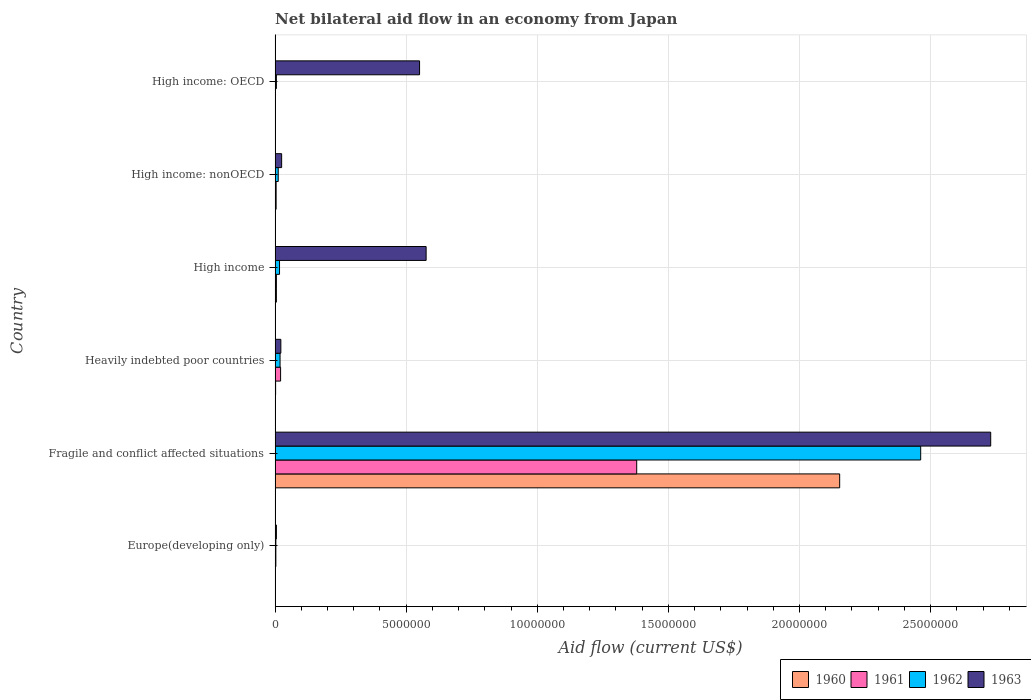How many different coloured bars are there?
Make the answer very short. 4. Are the number of bars per tick equal to the number of legend labels?
Offer a terse response. Yes. Are the number of bars on each tick of the Y-axis equal?
Provide a short and direct response. Yes. How many bars are there on the 4th tick from the bottom?
Offer a terse response. 4. What is the label of the 4th group of bars from the top?
Provide a succinct answer. Heavily indebted poor countries. Across all countries, what is the maximum net bilateral aid flow in 1962?
Offer a terse response. 2.46e+07. Across all countries, what is the minimum net bilateral aid flow in 1961?
Provide a succinct answer. 10000. In which country was the net bilateral aid flow in 1962 maximum?
Ensure brevity in your answer.  Fragile and conflict affected situations. In which country was the net bilateral aid flow in 1963 minimum?
Provide a succinct answer. Europe(developing only). What is the total net bilateral aid flow in 1960 in the graph?
Offer a very short reply. 2.17e+07. What is the difference between the net bilateral aid flow in 1960 in Europe(developing only) and that in Heavily indebted poor countries?
Make the answer very short. -10000. What is the difference between the net bilateral aid flow in 1962 in Heavily indebted poor countries and the net bilateral aid flow in 1960 in Fragile and conflict affected situations?
Provide a short and direct response. -2.13e+07. What is the average net bilateral aid flow in 1960 per country?
Offer a very short reply. 3.61e+06. What is the difference between the net bilateral aid flow in 1960 and net bilateral aid flow in 1961 in High income?
Provide a succinct answer. 0. In how many countries, is the net bilateral aid flow in 1962 greater than 26000000 US$?
Offer a very short reply. 0. What is the ratio of the net bilateral aid flow in 1961 in Heavily indebted poor countries to that in High income: nonOECD?
Your response must be concise. 5.25. What is the difference between the highest and the second highest net bilateral aid flow in 1960?
Make the answer very short. 2.15e+07. What is the difference between the highest and the lowest net bilateral aid flow in 1962?
Offer a terse response. 2.46e+07. What does the 3rd bar from the top in High income represents?
Provide a short and direct response. 1961. What does the 4th bar from the bottom in High income: OECD represents?
Make the answer very short. 1963. Are all the bars in the graph horizontal?
Your response must be concise. Yes. What is the difference between two consecutive major ticks on the X-axis?
Your response must be concise. 5.00e+06. Are the values on the major ticks of X-axis written in scientific E-notation?
Provide a succinct answer. No. Does the graph contain any zero values?
Keep it short and to the point. No. Does the graph contain grids?
Keep it short and to the point. Yes. How many legend labels are there?
Keep it short and to the point. 4. What is the title of the graph?
Your answer should be compact. Net bilateral aid flow in an economy from Japan. What is the label or title of the X-axis?
Your response must be concise. Aid flow (current US$). What is the label or title of the Y-axis?
Your answer should be compact. Country. What is the Aid flow (current US$) of 1963 in Europe(developing only)?
Offer a very short reply. 5.00e+04. What is the Aid flow (current US$) in 1960 in Fragile and conflict affected situations?
Your response must be concise. 2.15e+07. What is the Aid flow (current US$) of 1961 in Fragile and conflict affected situations?
Provide a short and direct response. 1.38e+07. What is the Aid flow (current US$) in 1962 in Fragile and conflict affected situations?
Ensure brevity in your answer.  2.46e+07. What is the Aid flow (current US$) in 1963 in Fragile and conflict affected situations?
Your response must be concise. 2.73e+07. What is the Aid flow (current US$) of 1960 in Heavily indebted poor countries?
Offer a terse response. 2.00e+04. What is the Aid flow (current US$) in 1962 in Heavily indebted poor countries?
Provide a succinct answer. 1.90e+05. What is the Aid flow (current US$) of 1961 in High income?
Offer a very short reply. 5.00e+04. What is the Aid flow (current US$) in 1963 in High income?
Offer a terse response. 5.76e+06. What is the Aid flow (current US$) of 1962 in High income: nonOECD?
Offer a very short reply. 1.20e+05. What is the Aid flow (current US$) of 1960 in High income: OECD?
Offer a terse response. 10000. What is the Aid flow (current US$) in 1961 in High income: OECD?
Offer a terse response. 10000. What is the Aid flow (current US$) in 1963 in High income: OECD?
Offer a terse response. 5.51e+06. Across all countries, what is the maximum Aid flow (current US$) in 1960?
Provide a short and direct response. 2.15e+07. Across all countries, what is the maximum Aid flow (current US$) in 1961?
Offer a very short reply. 1.38e+07. Across all countries, what is the maximum Aid flow (current US$) in 1962?
Keep it short and to the point. 2.46e+07. Across all countries, what is the maximum Aid flow (current US$) of 1963?
Give a very brief answer. 2.73e+07. Across all countries, what is the minimum Aid flow (current US$) of 1960?
Keep it short and to the point. 10000. Across all countries, what is the minimum Aid flow (current US$) in 1961?
Your answer should be compact. 10000. Across all countries, what is the minimum Aid flow (current US$) of 1962?
Your answer should be compact. 3.00e+04. Across all countries, what is the minimum Aid flow (current US$) in 1963?
Keep it short and to the point. 5.00e+04. What is the total Aid flow (current US$) in 1960 in the graph?
Keep it short and to the point. 2.17e+07. What is the total Aid flow (current US$) in 1961 in the graph?
Make the answer very short. 1.41e+07. What is the total Aid flow (current US$) of 1962 in the graph?
Give a very brief answer. 2.52e+07. What is the total Aid flow (current US$) in 1963 in the graph?
Provide a succinct answer. 3.91e+07. What is the difference between the Aid flow (current US$) in 1960 in Europe(developing only) and that in Fragile and conflict affected situations?
Provide a succinct answer. -2.15e+07. What is the difference between the Aid flow (current US$) in 1961 in Europe(developing only) and that in Fragile and conflict affected situations?
Your answer should be compact. -1.38e+07. What is the difference between the Aid flow (current US$) of 1962 in Europe(developing only) and that in Fragile and conflict affected situations?
Your answer should be very brief. -2.46e+07. What is the difference between the Aid flow (current US$) in 1963 in Europe(developing only) and that in Fragile and conflict affected situations?
Provide a short and direct response. -2.72e+07. What is the difference between the Aid flow (current US$) of 1962 in Europe(developing only) and that in Heavily indebted poor countries?
Ensure brevity in your answer.  -1.60e+05. What is the difference between the Aid flow (current US$) in 1961 in Europe(developing only) and that in High income?
Ensure brevity in your answer.  -2.00e+04. What is the difference between the Aid flow (current US$) in 1962 in Europe(developing only) and that in High income?
Make the answer very short. -1.40e+05. What is the difference between the Aid flow (current US$) of 1963 in Europe(developing only) and that in High income?
Your answer should be compact. -5.71e+06. What is the difference between the Aid flow (current US$) in 1960 in Europe(developing only) and that in High income: nonOECD?
Make the answer very short. -3.00e+04. What is the difference between the Aid flow (current US$) in 1961 in Europe(developing only) and that in High income: nonOECD?
Provide a short and direct response. -10000. What is the difference between the Aid flow (current US$) of 1963 in Europe(developing only) and that in High income: nonOECD?
Ensure brevity in your answer.  -2.00e+05. What is the difference between the Aid flow (current US$) of 1962 in Europe(developing only) and that in High income: OECD?
Offer a very short reply. -2.00e+04. What is the difference between the Aid flow (current US$) in 1963 in Europe(developing only) and that in High income: OECD?
Your answer should be compact. -5.46e+06. What is the difference between the Aid flow (current US$) in 1960 in Fragile and conflict affected situations and that in Heavily indebted poor countries?
Your answer should be compact. 2.15e+07. What is the difference between the Aid flow (current US$) of 1961 in Fragile and conflict affected situations and that in Heavily indebted poor countries?
Keep it short and to the point. 1.36e+07. What is the difference between the Aid flow (current US$) of 1962 in Fragile and conflict affected situations and that in Heavily indebted poor countries?
Make the answer very short. 2.44e+07. What is the difference between the Aid flow (current US$) of 1963 in Fragile and conflict affected situations and that in Heavily indebted poor countries?
Provide a succinct answer. 2.71e+07. What is the difference between the Aid flow (current US$) of 1960 in Fragile and conflict affected situations and that in High income?
Give a very brief answer. 2.15e+07. What is the difference between the Aid flow (current US$) of 1961 in Fragile and conflict affected situations and that in High income?
Your answer should be very brief. 1.37e+07. What is the difference between the Aid flow (current US$) of 1962 in Fragile and conflict affected situations and that in High income?
Provide a short and direct response. 2.44e+07. What is the difference between the Aid flow (current US$) of 1963 in Fragile and conflict affected situations and that in High income?
Ensure brevity in your answer.  2.15e+07. What is the difference between the Aid flow (current US$) of 1960 in Fragile and conflict affected situations and that in High income: nonOECD?
Your response must be concise. 2.15e+07. What is the difference between the Aid flow (current US$) in 1961 in Fragile and conflict affected situations and that in High income: nonOECD?
Keep it short and to the point. 1.38e+07. What is the difference between the Aid flow (current US$) of 1962 in Fragile and conflict affected situations and that in High income: nonOECD?
Provide a short and direct response. 2.45e+07. What is the difference between the Aid flow (current US$) of 1963 in Fragile and conflict affected situations and that in High income: nonOECD?
Your answer should be compact. 2.70e+07. What is the difference between the Aid flow (current US$) of 1960 in Fragile and conflict affected situations and that in High income: OECD?
Your response must be concise. 2.15e+07. What is the difference between the Aid flow (current US$) of 1961 in Fragile and conflict affected situations and that in High income: OECD?
Offer a terse response. 1.38e+07. What is the difference between the Aid flow (current US$) of 1962 in Fragile and conflict affected situations and that in High income: OECD?
Your answer should be compact. 2.46e+07. What is the difference between the Aid flow (current US$) of 1963 in Fragile and conflict affected situations and that in High income: OECD?
Your answer should be compact. 2.18e+07. What is the difference between the Aid flow (current US$) in 1963 in Heavily indebted poor countries and that in High income?
Provide a succinct answer. -5.54e+06. What is the difference between the Aid flow (current US$) in 1960 in Heavily indebted poor countries and that in High income: nonOECD?
Offer a terse response. -2.00e+04. What is the difference between the Aid flow (current US$) of 1961 in Heavily indebted poor countries and that in High income: nonOECD?
Your response must be concise. 1.70e+05. What is the difference between the Aid flow (current US$) of 1962 in Heavily indebted poor countries and that in High income: nonOECD?
Provide a short and direct response. 7.00e+04. What is the difference between the Aid flow (current US$) of 1961 in Heavily indebted poor countries and that in High income: OECD?
Offer a very short reply. 2.00e+05. What is the difference between the Aid flow (current US$) of 1963 in Heavily indebted poor countries and that in High income: OECD?
Provide a succinct answer. -5.29e+06. What is the difference between the Aid flow (current US$) in 1962 in High income and that in High income: nonOECD?
Your answer should be very brief. 5.00e+04. What is the difference between the Aid flow (current US$) in 1963 in High income and that in High income: nonOECD?
Provide a succinct answer. 5.51e+06. What is the difference between the Aid flow (current US$) of 1960 in High income and that in High income: OECD?
Your answer should be compact. 4.00e+04. What is the difference between the Aid flow (current US$) of 1961 in High income and that in High income: OECD?
Your answer should be very brief. 4.00e+04. What is the difference between the Aid flow (current US$) of 1962 in High income and that in High income: OECD?
Offer a very short reply. 1.20e+05. What is the difference between the Aid flow (current US$) of 1963 in High income and that in High income: OECD?
Ensure brevity in your answer.  2.50e+05. What is the difference between the Aid flow (current US$) in 1961 in High income: nonOECD and that in High income: OECD?
Ensure brevity in your answer.  3.00e+04. What is the difference between the Aid flow (current US$) of 1962 in High income: nonOECD and that in High income: OECD?
Make the answer very short. 7.00e+04. What is the difference between the Aid flow (current US$) of 1963 in High income: nonOECD and that in High income: OECD?
Offer a very short reply. -5.26e+06. What is the difference between the Aid flow (current US$) in 1960 in Europe(developing only) and the Aid flow (current US$) in 1961 in Fragile and conflict affected situations?
Provide a succinct answer. -1.38e+07. What is the difference between the Aid flow (current US$) in 1960 in Europe(developing only) and the Aid flow (current US$) in 1962 in Fragile and conflict affected situations?
Provide a succinct answer. -2.46e+07. What is the difference between the Aid flow (current US$) in 1960 in Europe(developing only) and the Aid flow (current US$) in 1963 in Fragile and conflict affected situations?
Provide a succinct answer. -2.73e+07. What is the difference between the Aid flow (current US$) of 1961 in Europe(developing only) and the Aid flow (current US$) of 1962 in Fragile and conflict affected situations?
Offer a very short reply. -2.46e+07. What is the difference between the Aid flow (current US$) in 1961 in Europe(developing only) and the Aid flow (current US$) in 1963 in Fragile and conflict affected situations?
Your answer should be very brief. -2.73e+07. What is the difference between the Aid flow (current US$) of 1962 in Europe(developing only) and the Aid flow (current US$) of 1963 in Fragile and conflict affected situations?
Your answer should be very brief. -2.73e+07. What is the difference between the Aid flow (current US$) in 1960 in Europe(developing only) and the Aid flow (current US$) in 1961 in Heavily indebted poor countries?
Your answer should be compact. -2.00e+05. What is the difference between the Aid flow (current US$) in 1961 in Europe(developing only) and the Aid flow (current US$) in 1962 in Heavily indebted poor countries?
Provide a short and direct response. -1.60e+05. What is the difference between the Aid flow (current US$) of 1962 in Europe(developing only) and the Aid flow (current US$) of 1963 in Heavily indebted poor countries?
Your answer should be compact. -1.90e+05. What is the difference between the Aid flow (current US$) in 1960 in Europe(developing only) and the Aid flow (current US$) in 1961 in High income?
Your response must be concise. -4.00e+04. What is the difference between the Aid flow (current US$) of 1960 in Europe(developing only) and the Aid flow (current US$) of 1962 in High income?
Keep it short and to the point. -1.60e+05. What is the difference between the Aid flow (current US$) of 1960 in Europe(developing only) and the Aid flow (current US$) of 1963 in High income?
Your response must be concise. -5.75e+06. What is the difference between the Aid flow (current US$) of 1961 in Europe(developing only) and the Aid flow (current US$) of 1963 in High income?
Your answer should be very brief. -5.73e+06. What is the difference between the Aid flow (current US$) in 1962 in Europe(developing only) and the Aid flow (current US$) in 1963 in High income?
Provide a short and direct response. -5.73e+06. What is the difference between the Aid flow (current US$) in 1960 in Europe(developing only) and the Aid flow (current US$) in 1961 in High income: nonOECD?
Offer a very short reply. -3.00e+04. What is the difference between the Aid flow (current US$) of 1961 in Europe(developing only) and the Aid flow (current US$) of 1962 in High income: nonOECD?
Make the answer very short. -9.00e+04. What is the difference between the Aid flow (current US$) of 1961 in Europe(developing only) and the Aid flow (current US$) of 1963 in High income: nonOECD?
Provide a succinct answer. -2.20e+05. What is the difference between the Aid flow (current US$) of 1960 in Europe(developing only) and the Aid flow (current US$) of 1961 in High income: OECD?
Give a very brief answer. 0. What is the difference between the Aid flow (current US$) in 1960 in Europe(developing only) and the Aid flow (current US$) in 1962 in High income: OECD?
Ensure brevity in your answer.  -4.00e+04. What is the difference between the Aid flow (current US$) of 1960 in Europe(developing only) and the Aid flow (current US$) of 1963 in High income: OECD?
Provide a succinct answer. -5.50e+06. What is the difference between the Aid flow (current US$) of 1961 in Europe(developing only) and the Aid flow (current US$) of 1963 in High income: OECD?
Your answer should be compact. -5.48e+06. What is the difference between the Aid flow (current US$) in 1962 in Europe(developing only) and the Aid flow (current US$) in 1963 in High income: OECD?
Make the answer very short. -5.48e+06. What is the difference between the Aid flow (current US$) in 1960 in Fragile and conflict affected situations and the Aid flow (current US$) in 1961 in Heavily indebted poor countries?
Provide a succinct answer. 2.13e+07. What is the difference between the Aid flow (current US$) in 1960 in Fragile and conflict affected situations and the Aid flow (current US$) in 1962 in Heavily indebted poor countries?
Your answer should be very brief. 2.13e+07. What is the difference between the Aid flow (current US$) of 1960 in Fragile and conflict affected situations and the Aid flow (current US$) of 1963 in Heavily indebted poor countries?
Your answer should be very brief. 2.13e+07. What is the difference between the Aid flow (current US$) of 1961 in Fragile and conflict affected situations and the Aid flow (current US$) of 1962 in Heavily indebted poor countries?
Keep it short and to the point. 1.36e+07. What is the difference between the Aid flow (current US$) of 1961 in Fragile and conflict affected situations and the Aid flow (current US$) of 1963 in Heavily indebted poor countries?
Offer a terse response. 1.36e+07. What is the difference between the Aid flow (current US$) in 1962 in Fragile and conflict affected situations and the Aid flow (current US$) in 1963 in Heavily indebted poor countries?
Ensure brevity in your answer.  2.44e+07. What is the difference between the Aid flow (current US$) in 1960 in Fragile and conflict affected situations and the Aid flow (current US$) in 1961 in High income?
Your answer should be very brief. 2.15e+07. What is the difference between the Aid flow (current US$) in 1960 in Fragile and conflict affected situations and the Aid flow (current US$) in 1962 in High income?
Make the answer very short. 2.14e+07. What is the difference between the Aid flow (current US$) of 1960 in Fragile and conflict affected situations and the Aid flow (current US$) of 1963 in High income?
Provide a succinct answer. 1.58e+07. What is the difference between the Aid flow (current US$) of 1961 in Fragile and conflict affected situations and the Aid flow (current US$) of 1962 in High income?
Give a very brief answer. 1.36e+07. What is the difference between the Aid flow (current US$) in 1961 in Fragile and conflict affected situations and the Aid flow (current US$) in 1963 in High income?
Provide a succinct answer. 8.03e+06. What is the difference between the Aid flow (current US$) of 1962 in Fragile and conflict affected situations and the Aid flow (current US$) of 1963 in High income?
Make the answer very short. 1.89e+07. What is the difference between the Aid flow (current US$) in 1960 in Fragile and conflict affected situations and the Aid flow (current US$) in 1961 in High income: nonOECD?
Your answer should be very brief. 2.15e+07. What is the difference between the Aid flow (current US$) of 1960 in Fragile and conflict affected situations and the Aid flow (current US$) of 1962 in High income: nonOECD?
Provide a short and direct response. 2.14e+07. What is the difference between the Aid flow (current US$) of 1960 in Fragile and conflict affected situations and the Aid flow (current US$) of 1963 in High income: nonOECD?
Your answer should be very brief. 2.13e+07. What is the difference between the Aid flow (current US$) in 1961 in Fragile and conflict affected situations and the Aid flow (current US$) in 1962 in High income: nonOECD?
Give a very brief answer. 1.37e+07. What is the difference between the Aid flow (current US$) of 1961 in Fragile and conflict affected situations and the Aid flow (current US$) of 1963 in High income: nonOECD?
Ensure brevity in your answer.  1.35e+07. What is the difference between the Aid flow (current US$) of 1962 in Fragile and conflict affected situations and the Aid flow (current US$) of 1963 in High income: nonOECD?
Your response must be concise. 2.44e+07. What is the difference between the Aid flow (current US$) in 1960 in Fragile and conflict affected situations and the Aid flow (current US$) in 1961 in High income: OECD?
Make the answer very short. 2.15e+07. What is the difference between the Aid flow (current US$) in 1960 in Fragile and conflict affected situations and the Aid flow (current US$) in 1962 in High income: OECD?
Provide a short and direct response. 2.15e+07. What is the difference between the Aid flow (current US$) of 1960 in Fragile and conflict affected situations and the Aid flow (current US$) of 1963 in High income: OECD?
Provide a short and direct response. 1.60e+07. What is the difference between the Aid flow (current US$) in 1961 in Fragile and conflict affected situations and the Aid flow (current US$) in 1962 in High income: OECD?
Your answer should be compact. 1.37e+07. What is the difference between the Aid flow (current US$) of 1961 in Fragile and conflict affected situations and the Aid flow (current US$) of 1963 in High income: OECD?
Your response must be concise. 8.28e+06. What is the difference between the Aid flow (current US$) in 1962 in Fragile and conflict affected situations and the Aid flow (current US$) in 1963 in High income: OECD?
Offer a terse response. 1.91e+07. What is the difference between the Aid flow (current US$) of 1960 in Heavily indebted poor countries and the Aid flow (current US$) of 1963 in High income?
Your answer should be very brief. -5.74e+06. What is the difference between the Aid flow (current US$) in 1961 in Heavily indebted poor countries and the Aid flow (current US$) in 1962 in High income?
Offer a terse response. 4.00e+04. What is the difference between the Aid flow (current US$) of 1961 in Heavily indebted poor countries and the Aid flow (current US$) of 1963 in High income?
Keep it short and to the point. -5.55e+06. What is the difference between the Aid flow (current US$) of 1962 in Heavily indebted poor countries and the Aid flow (current US$) of 1963 in High income?
Keep it short and to the point. -5.57e+06. What is the difference between the Aid flow (current US$) in 1960 in Heavily indebted poor countries and the Aid flow (current US$) in 1963 in High income: nonOECD?
Provide a short and direct response. -2.30e+05. What is the difference between the Aid flow (current US$) of 1961 in Heavily indebted poor countries and the Aid flow (current US$) of 1963 in High income: nonOECD?
Offer a terse response. -4.00e+04. What is the difference between the Aid flow (current US$) in 1960 in Heavily indebted poor countries and the Aid flow (current US$) in 1963 in High income: OECD?
Offer a very short reply. -5.49e+06. What is the difference between the Aid flow (current US$) in 1961 in Heavily indebted poor countries and the Aid flow (current US$) in 1963 in High income: OECD?
Provide a succinct answer. -5.30e+06. What is the difference between the Aid flow (current US$) of 1962 in Heavily indebted poor countries and the Aid flow (current US$) of 1963 in High income: OECD?
Provide a succinct answer. -5.32e+06. What is the difference between the Aid flow (current US$) of 1960 in High income and the Aid flow (current US$) of 1961 in High income: nonOECD?
Your answer should be very brief. 10000. What is the difference between the Aid flow (current US$) in 1961 in High income and the Aid flow (current US$) in 1962 in High income: nonOECD?
Offer a very short reply. -7.00e+04. What is the difference between the Aid flow (current US$) in 1961 in High income and the Aid flow (current US$) in 1963 in High income: nonOECD?
Your response must be concise. -2.00e+05. What is the difference between the Aid flow (current US$) of 1960 in High income and the Aid flow (current US$) of 1961 in High income: OECD?
Give a very brief answer. 4.00e+04. What is the difference between the Aid flow (current US$) in 1960 in High income and the Aid flow (current US$) in 1962 in High income: OECD?
Ensure brevity in your answer.  0. What is the difference between the Aid flow (current US$) of 1960 in High income and the Aid flow (current US$) of 1963 in High income: OECD?
Offer a very short reply. -5.46e+06. What is the difference between the Aid flow (current US$) of 1961 in High income and the Aid flow (current US$) of 1962 in High income: OECD?
Provide a succinct answer. 0. What is the difference between the Aid flow (current US$) of 1961 in High income and the Aid flow (current US$) of 1963 in High income: OECD?
Provide a short and direct response. -5.46e+06. What is the difference between the Aid flow (current US$) of 1962 in High income and the Aid flow (current US$) of 1963 in High income: OECD?
Ensure brevity in your answer.  -5.34e+06. What is the difference between the Aid flow (current US$) in 1960 in High income: nonOECD and the Aid flow (current US$) in 1961 in High income: OECD?
Your answer should be very brief. 3.00e+04. What is the difference between the Aid flow (current US$) in 1960 in High income: nonOECD and the Aid flow (current US$) in 1963 in High income: OECD?
Give a very brief answer. -5.47e+06. What is the difference between the Aid flow (current US$) in 1961 in High income: nonOECD and the Aid flow (current US$) in 1962 in High income: OECD?
Offer a terse response. -10000. What is the difference between the Aid flow (current US$) in 1961 in High income: nonOECD and the Aid flow (current US$) in 1963 in High income: OECD?
Your answer should be compact. -5.47e+06. What is the difference between the Aid flow (current US$) of 1962 in High income: nonOECD and the Aid flow (current US$) of 1963 in High income: OECD?
Make the answer very short. -5.39e+06. What is the average Aid flow (current US$) in 1960 per country?
Keep it short and to the point. 3.61e+06. What is the average Aid flow (current US$) of 1961 per country?
Keep it short and to the point. 2.36e+06. What is the average Aid flow (current US$) of 1962 per country?
Your answer should be compact. 4.20e+06. What is the average Aid flow (current US$) in 1963 per country?
Give a very brief answer. 6.51e+06. What is the difference between the Aid flow (current US$) of 1960 and Aid flow (current US$) of 1961 in Europe(developing only)?
Keep it short and to the point. -2.00e+04. What is the difference between the Aid flow (current US$) in 1960 and Aid flow (current US$) in 1963 in Europe(developing only)?
Make the answer very short. -4.00e+04. What is the difference between the Aid flow (current US$) of 1962 and Aid flow (current US$) of 1963 in Europe(developing only)?
Your response must be concise. -2.00e+04. What is the difference between the Aid flow (current US$) of 1960 and Aid flow (current US$) of 1961 in Fragile and conflict affected situations?
Keep it short and to the point. 7.74e+06. What is the difference between the Aid flow (current US$) of 1960 and Aid flow (current US$) of 1962 in Fragile and conflict affected situations?
Keep it short and to the point. -3.09e+06. What is the difference between the Aid flow (current US$) in 1960 and Aid flow (current US$) in 1963 in Fragile and conflict affected situations?
Offer a terse response. -5.76e+06. What is the difference between the Aid flow (current US$) of 1961 and Aid flow (current US$) of 1962 in Fragile and conflict affected situations?
Provide a short and direct response. -1.08e+07. What is the difference between the Aid flow (current US$) in 1961 and Aid flow (current US$) in 1963 in Fragile and conflict affected situations?
Give a very brief answer. -1.35e+07. What is the difference between the Aid flow (current US$) in 1962 and Aid flow (current US$) in 1963 in Fragile and conflict affected situations?
Your answer should be compact. -2.67e+06. What is the difference between the Aid flow (current US$) of 1960 and Aid flow (current US$) of 1961 in Heavily indebted poor countries?
Keep it short and to the point. -1.90e+05. What is the difference between the Aid flow (current US$) in 1960 and Aid flow (current US$) in 1962 in Heavily indebted poor countries?
Your answer should be very brief. -1.70e+05. What is the difference between the Aid flow (current US$) in 1961 and Aid flow (current US$) in 1962 in Heavily indebted poor countries?
Give a very brief answer. 2.00e+04. What is the difference between the Aid flow (current US$) of 1961 and Aid flow (current US$) of 1963 in Heavily indebted poor countries?
Your response must be concise. -10000. What is the difference between the Aid flow (current US$) of 1962 and Aid flow (current US$) of 1963 in Heavily indebted poor countries?
Provide a succinct answer. -3.00e+04. What is the difference between the Aid flow (current US$) of 1960 and Aid flow (current US$) of 1963 in High income?
Offer a very short reply. -5.71e+06. What is the difference between the Aid flow (current US$) in 1961 and Aid flow (current US$) in 1963 in High income?
Provide a succinct answer. -5.71e+06. What is the difference between the Aid flow (current US$) in 1962 and Aid flow (current US$) in 1963 in High income?
Provide a short and direct response. -5.59e+06. What is the difference between the Aid flow (current US$) of 1960 and Aid flow (current US$) of 1961 in High income: nonOECD?
Provide a short and direct response. 0. What is the difference between the Aid flow (current US$) in 1960 and Aid flow (current US$) in 1963 in High income: nonOECD?
Provide a succinct answer. -2.10e+05. What is the difference between the Aid flow (current US$) of 1960 and Aid flow (current US$) of 1961 in High income: OECD?
Ensure brevity in your answer.  0. What is the difference between the Aid flow (current US$) in 1960 and Aid flow (current US$) in 1962 in High income: OECD?
Your answer should be very brief. -4.00e+04. What is the difference between the Aid flow (current US$) of 1960 and Aid flow (current US$) of 1963 in High income: OECD?
Your answer should be compact. -5.50e+06. What is the difference between the Aid flow (current US$) in 1961 and Aid flow (current US$) in 1962 in High income: OECD?
Your answer should be very brief. -4.00e+04. What is the difference between the Aid flow (current US$) of 1961 and Aid flow (current US$) of 1963 in High income: OECD?
Your answer should be compact. -5.50e+06. What is the difference between the Aid flow (current US$) of 1962 and Aid flow (current US$) of 1963 in High income: OECD?
Your response must be concise. -5.46e+06. What is the ratio of the Aid flow (current US$) in 1961 in Europe(developing only) to that in Fragile and conflict affected situations?
Ensure brevity in your answer.  0. What is the ratio of the Aid flow (current US$) of 1962 in Europe(developing only) to that in Fragile and conflict affected situations?
Provide a succinct answer. 0. What is the ratio of the Aid flow (current US$) of 1963 in Europe(developing only) to that in Fragile and conflict affected situations?
Provide a succinct answer. 0. What is the ratio of the Aid flow (current US$) in 1961 in Europe(developing only) to that in Heavily indebted poor countries?
Offer a very short reply. 0.14. What is the ratio of the Aid flow (current US$) of 1962 in Europe(developing only) to that in Heavily indebted poor countries?
Ensure brevity in your answer.  0.16. What is the ratio of the Aid flow (current US$) of 1963 in Europe(developing only) to that in Heavily indebted poor countries?
Keep it short and to the point. 0.23. What is the ratio of the Aid flow (current US$) in 1960 in Europe(developing only) to that in High income?
Your response must be concise. 0.2. What is the ratio of the Aid flow (current US$) in 1961 in Europe(developing only) to that in High income?
Your answer should be very brief. 0.6. What is the ratio of the Aid flow (current US$) in 1962 in Europe(developing only) to that in High income?
Your answer should be very brief. 0.18. What is the ratio of the Aid flow (current US$) in 1963 in Europe(developing only) to that in High income?
Give a very brief answer. 0.01. What is the ratio of the Aid flow (current US$) of 1961 in Europe(developing only) to that in High income: nonOECD?
Give a very brief answer. 0.75. What is the ratio of the Aid flow (current US$) in 1962 in Europe(developing only) to that in High income: OECD?
Offer a terse response. 0.6. What is the ratio of the Aid flow (current US$) in 1963 in Europe(developing only) to that in High income: OECD?
Your answer should be very brief. 0.01. What is the ratio of the Aid flow (current US$) of 1960 in Fragile and conflict affected situations to that in Heavily indebted poor countries?
Give a very brief answer. 1076.5. What is the ratio of the Aid flow (current US$) in 1961 in Fragile and conflict affected situations to that in Heavily indebted poor countries?
Provide a short and direct response. 65.67. What is the ratio of the Aid flow (current US$) of 1962 in Fragile and conflict affected situations to that in Heavily indebted poor countries?
Your response must be concise. 129.58. What is the ratio of the Aid flow (current US$) in 1963 in Fragile and conflict affected situations to that in Heavily indebted poor countries?
Give a very brief answer. 124.05. What is the ratio of the Aid flow (current US$) of 1960 in Fragile and conflict affected situations to that in High income?
Keep it short and to the point. 430.6. What is the ratio of the Aid flow (current US$) of 1961 in Fragile and conflict affected situations to that in High income?
Give a very brief answer. 275.8. What is the ratio of the Aid flow (current US$) in 1962 in Fragile and conflict affected situations to that in High income?
Offer a very short reply. 144.82. What is the ratio of the Aid flow (current US$) of 1963 in Fragile and conflict affected situations to that in High income?
Offer a very short reply. 4.74. What is the ratio of the Aid flow (current US$) of 1960 in Fragile and conflict affected situations to that in High income: nonOECD?
Ensure brevity in your answer.  538.25. What is the ratio of the Aid flow (current US$) in 1961 in Fragile and conflict affected situations to that in High income: nonOECD?
Make the answer very short. 344.75. What is the ratio of the Aid flow (current US$) of 1962 in Fragile and conflict affected situations to that in High income: nonOECD?
Give a very brief answer. 205.17. What is the ratio of the Aid flow (current US$) in 1963 in Fragile and conflict affected situations to that in High income: nonOECD?
Your answer should be very brief. 109.16. What is the ratio of the Aid flow (current US$) of 1960 in Fragile and conflict affected situations to that in High income: OECD?
Your answer should be compact. 2153. What is the ratio of the Aid flow (current US$) of 1961 in Fragile and conflict affected situations to that in High income: OECD?
Provide a succinct answer. 1379. What is the ratio of the Aid flow (current US$) of 1962 in Fragile and conflict affected situations to that in High income: OECD?
Provide a short and direct response. 492.4. What is the ratio of the Aid flow (current US$) in 1963 in Fragile and conflict affected situations to that in High income: OECD?
Make the answer very short. 4.95. What is the ratio of the Aid flow (current US$) in 1960 in Heavily indebted poor countries to that in High income?
Offer a very short reply. 0.4. What is the ratio of the Aid flow (current US$) in 1961 in Heavily indebted poor countries to that in High income?
Offer a very short reply. 4.2. What is the ratio of the Aid flow (current US$) of 1962 in Heavily indebted poor countries to that in High income?
Offer a terse response. 1.12. What is the ratio of the Aid flow (current US$) of 1963 in Heavily indebted poor countries to that in High income?
Offer a terse response. 0.04. What is the ratio of the Aid flow (current US$) in 1961 in Heavily indebted poor countries to that in High income: nonOECD?
Keep it short and to the point. 5.25. What is the ratio of the Aid flow (current US$) of 1962 in Heavily indebted poor countries to that in High income: nonOECD?
Offer a very short reply. 1.58. What is the ratio of the Aid flow (current US$) in 1963 in Heavily indebted poor countries to that in High income: OECD?
Your answer should be very brief. 0.04. What is the ratio of the Aid flow (current US$) of 1960 in High income to that in High income: nonOECD?
Your answer should be very brief. 1.25. What is the ratio of the Aid flow (current US$) in 1962 in High income to that in High income: nonOECD?
Your answer should be compact. 1.42. What is the ratio of the Aid flow (current US$) of 1963 in High income to that in High income: nonOECD?
Offer a very short reply. 23.04. What is the ratio of the Aid flow (current US$) in 1960 in High income to that in High income: OECD?
Your response must be concise. 5. What is the ratio of the Aid flow (current US$) in 1963 in High income to that in High income: OECD?
Your answer should be compact. 1.05. What is the ratio of the Aid flow (current US$) of 1960 in High income: nonOECD to that in High income: OECD?
Give a very brief answer. 4. What is the ratio of the Aid flow (current US$) in 1962 in High income: nonOECD to that in High income: OECD?
Your response must be concise. 2.4. What is the ratio of the Aid flow (current US$) in 1963 in High income: nonOECD to that in High income: OECD?
Your answer should be very brief. 0.05. What is the difference between the highest and the second highest Aid flow (current US$) in 1960?
Offer a terse response. 2.15e+07. What is the difference between the highest and the second highest Aid flow (current US$) in 1961?
Give a very brief answer. 1.36e+07. What is the difference between the highest and the second highest Aid flow (current US$) of 1962?
Provide a succinct answer. 2.44e+07. What is the difference between the highest and the second highest Aid flow (current US$) of 1963?
Your answer should be compact. 2.15e+07. What is the difference between the highest and the lowest Aid flow (current US$) of 1960?
Your answer should be compact. 2.15e+07. What is the difference between the highest and the lowest Aid flow (current US$) in 1961?
Ensure brevity in your answer.  1.38e+07. What is the difference between the highest and the lowest Aid flow (current US$) of 1962?
Your response must be concise. 2.46e+07. What is the difference between the highest and the lowest Aid flow (current US$) of 1963?
Make the answer very short. 2.72e+07. 